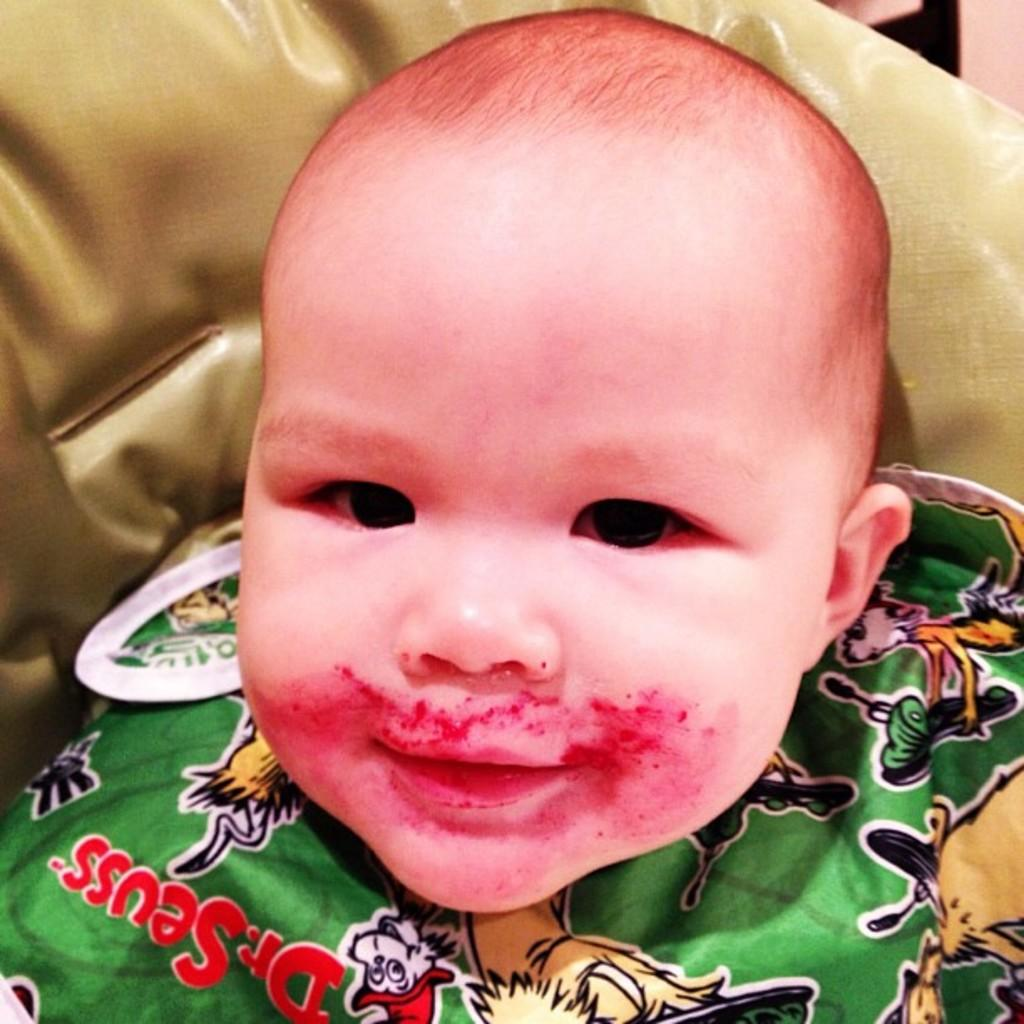What is the main subject in the foreground of the image? There is a baby in the foreground of the image. What can be seen in the background of the image? There is a couch in the background of the image. What type of monkey is sitting on the baby's shoulder in the image? There is no monkey present in the image; the main subject is a baby. How many birds can be seen flying around the couch in the background? There are no birds visible in the image; the background setting only includes a couch. 